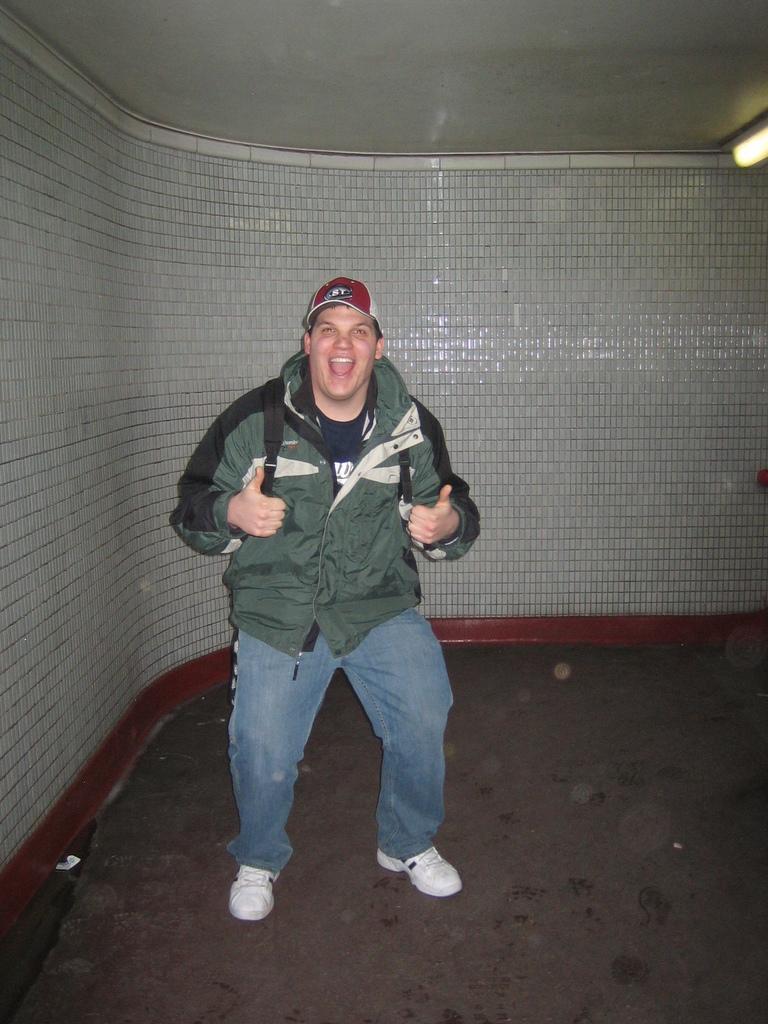In one or two sentences, can you explain what this image depicts? In this image I can see a person standing and wearing green and black color jacket and jeans. He is wearing a bag. Back I can see a white and maroon color wall. 